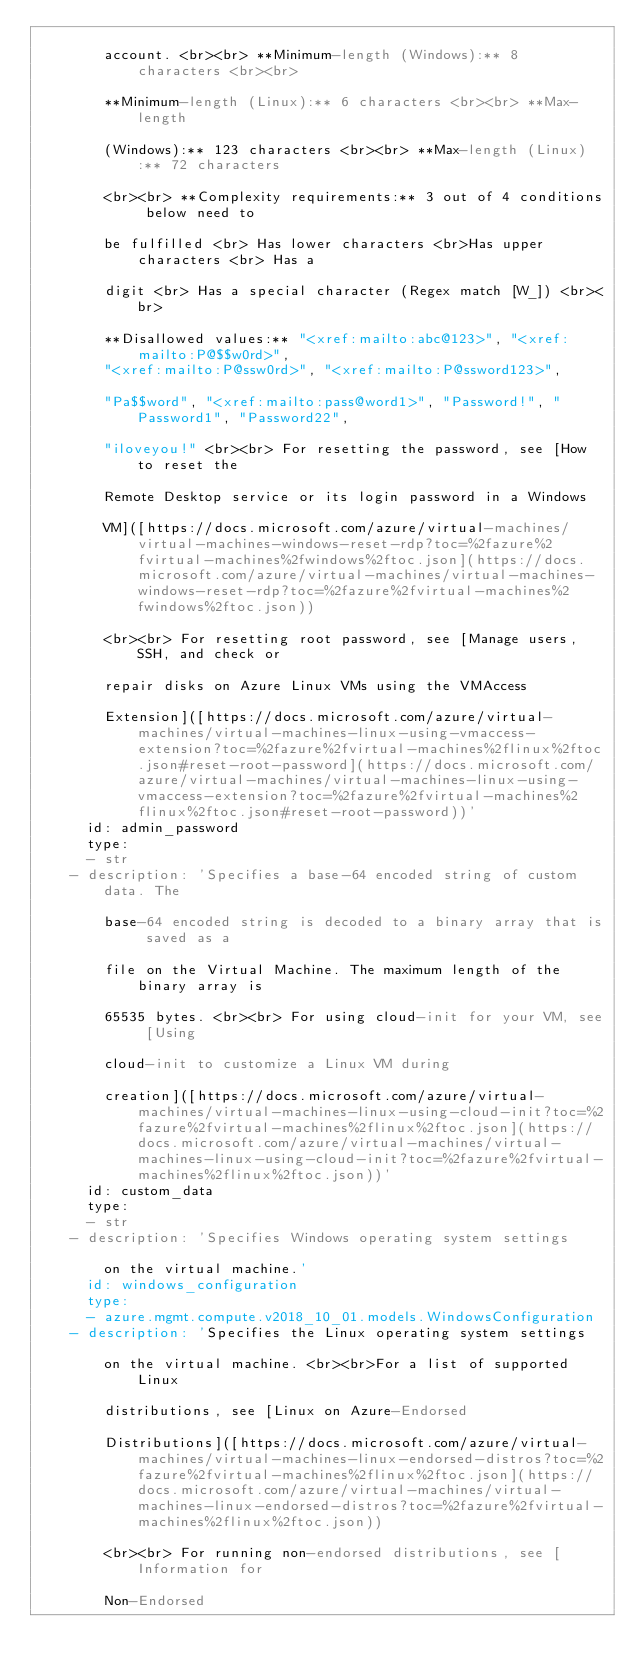Convert code to text. <code><loc_0><loc_0><loc_500><loc_500><_YAML_>
        account. <br><br> **Minimum-length (Windows):** 8 characters <br><br>

        **Minimum-length (Linux):** 6 characters <br><br> **Max-length

        (Windows):** 123 characters <br><br> **Max-length (Linux):** 72 characters

        <br><br> **Complexity requirements:** 3 out of 4 conditions below need to

        be fulfilled <br> Has lower characters <br>Has upper characters <br> Has a

        digit <br> Has a special character (Regex match [W_]) <br><br>

        **Disallowed values:** "<xref:mailto:abc@123>", "<xref:mailto:P@$$w0rd>",
        "<xref:mailto:P@ssw0rd>", "<xref:mailto:P@ssword123>",

        "Pa$$word", "<xref:mailto:pass@word1>", "Password!", "Password1", "Password22",

        "iloveyou!" <br><br> For resetting the password, see [How to reset the

        Remote Desktop service or its login password in a Windows

        VM]([https://docs.microsoft.com/azure/virtual-machines/virtual-machines-windows-reset-rdp?toc=%2fazure%2fvirtual-machines%2fwindows%2ftoc.json](https://docs.microsoft.com/azure/virtual-machines/virtual-machines-windows-reset-rdp?toc=%2fazure%2fvirtual-machines%2fwindows%2ftoc.json))

        <br><br> For resetting root password, see [Manage users, SSH, and check or

        repair disks on Azure Linux VMs using the VMAccess

        Extension]([https://docs.microsoft.com/azure/virtual-machines/virtual-machines-linux-using-vmaccess-extension?toc=%2fazure%2fvirtual-machines%2flinux%2ftoc.json#reset-root-password](https://docs.microsoft.com/azure/virtual-machines/virtual-machines-linux-using-vmaccess-extension?toc=%2fazure%2fvirtual-machines%2flinux%2ftoc.json#reset-root-password))'
      id: admin_password
      type:
      - str
    - description: 'Specifies a base-64 encoded string of custom data. The

        base-64 encoded string is decoded to a binary array that is saved as a

        file on the Virtual Machine. The maximum length of the binary array is

        65535 bytes. <br><br> For using cloud-init for your VM, see [Using

        cloud-init to customize a Linux VM during

        creation]([https://docs.microsoft.com/azure/virtual-machines/virtual-machines-linux-using-cloud-init?toc=%2fazure%2fvirtual-machines%2flinux%2ftoc.json](https://docs.microsoft.com/azure/virtual-machines/virtual-machines-linux-using-cloud-init?toc=%2fazure%2fvirtual-machines%2flinux%2ftoc.json))'
      id: custom_data
      type:
      - str
    - description: 'Specifies Windows operating system settings

        on the virtual machine.'
      id: windows_configuration
      type:
      - azure.mgmt.compute.v2018_10_01.models.WindowsConfiguration
    - description: 'Specifies the Linux operating system settings

        on the virtual machine. <br><br>For a list of supported Linux

        distributions, see [Linux on Azure-Endorsed

        Distributions]([https://docs.microsoft.com/azure/virtual-machines/virtual-machines-linux-endorsed-distros?toc=%2fazure%2fvirtual-machines%2flinux%2ftoc.json](https://docs.microsoft.com/azure/virtual-machines/virtual-machines-linux-endorsed-distros?toc=%2fazure%2fvirtual-machines%2flinux%2ftoc.json))

        <br><br> For running non-endorsed distributions, see [Information for

        Non-Endorsed
</code> 